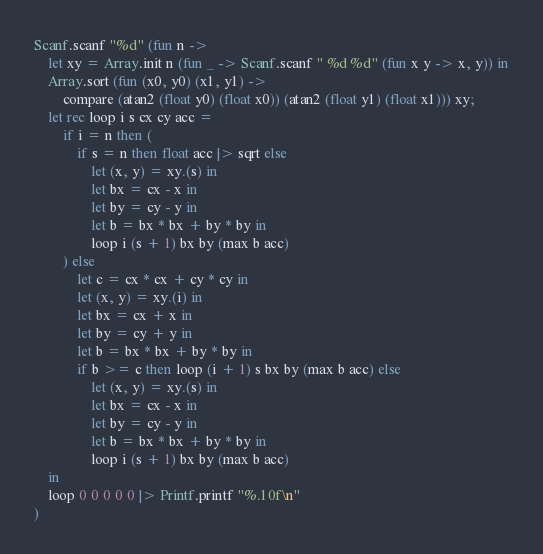<code> <loc_0><loc_0><loc_500><loc_500><_OCaml_>Scanf.scanf "%d" (fun n ->
    let xy = Array.init n (fun _ -> Scanf.scanf " %d %d" (fun x y -> x, y)) in
    Array.sort (fun (x0, y0) (x1, y1) ->
        compare (atan2 (float y0) (float x0)) (atan2 (float y1) (float x1))) xy;
    let rec loop i s cx cy acc =
        if i = n then (
            if s = n then float acc |> sqrt else
                let (x, y) = xy.(s) in
                let bx = cx - x in
                let by = cy - y in
                let b = bx * bx + by * by in
                loop i (s + 1) bx by (max b acc)
        ) else
            let c = cx * cx + cy * cy in
            let (x, y) = xy.(i) in
            let bx = cx + x in
            let by = cy + y in
            let b = bx * bx + by * by in
            if b >= c then loop (i + 1) s bx by (max b acc) else
                let (x, y) = xy.(s) in
                let bx = cx - x in
                let by = cy - y in
                let b = bx * bx + by * by in
                loop i (s + 1) bx by (max b acc)
    in
    loop 0 0 0 0 0 |> Printf.printf "%.10f\n"
)</code> 